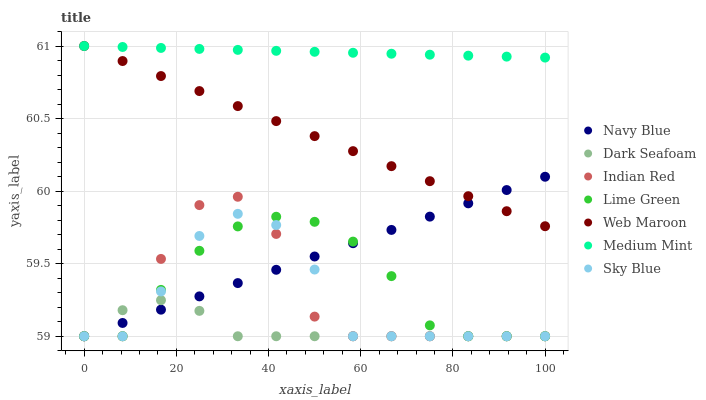Does Dark Seafoam have the minimum area under the curve?
Answer yes or no. Yes. Does Medium Mint have the maximum area under the curve?
Answer yes or no. Yes. Does Navy Blue have the minimum area under the curve?
Answer yes or no. No. Does Navy Blue have the maximum area under the curve?
Answer yes or no. No. Is Medium Mint the smoothest?
Answer yes or no. Yes. Is Indian Red the roughest?
Answer yes or no. Yes. Is Navy Blue the smoothest?
Answer yes or no. No. Is Navy Blue the roughest?
Answer yes or no. No. Does Navy Blue have the lowest value?
Answer yes or no. Yes. Does Web Maroon have the lowest value?
Answer yes or no. No. Does Web Maroon have the highest value?
Answer yes or no. Yes. Does Navy Blue have the highest value?
Answer yes or no. No. Is Dark Seafoam less than Web Maroon?
Answer yes or no. Yes. Is Web Maroon greater than Dark Seafoam?
Answer yes or no. Yes. Does Navy Blue intersect Dark Seafoam?
Answer yes or no. Yes. Is Navy Blue less than Dark Seafoam?
Answer yes or no. No. Is Navy Blue greater than Dark Seafoam?
Answer yes or no. No. Does Dark Seafoam intersect Web Maroon?
Answer yes or no. No. 